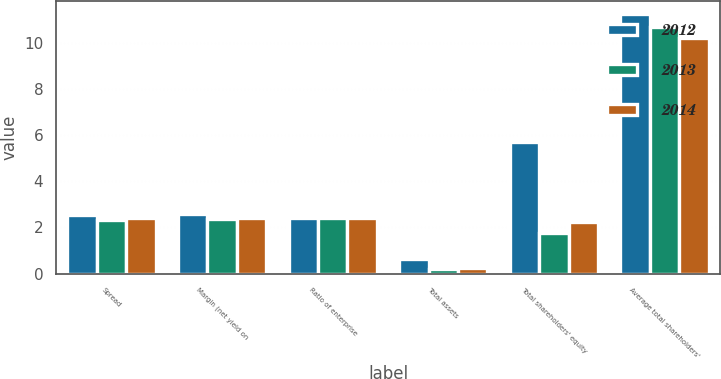Convert chart to OTSL. <chart><loc_0><loc_0><loc_500><loc_500><stacked_bar_chart><ecel><fcel>Spread<fcel>Margin (net yield on<fcel>Ratio of enterprise<fcel>Total assets<fcel>Total shareholders' equity<fcel>Average total shareholders'<nl><fcel>2012<fcel>2.55<fcel>2.59<fcel>2.39<fcel>0.64<fcel>5.69<fcel>11.26<nl><fcel>2013<fcel>2.33<fcel>2.37<fcel>2.39<fcel>0.19<fcel>1.77<fcel>10.7<nl><fcel>2014<fcel>2.39<fcel>2.43<fcel>2.39<fcel>0.23<fcel>2.24<fcel>10.19<nl></chart> 